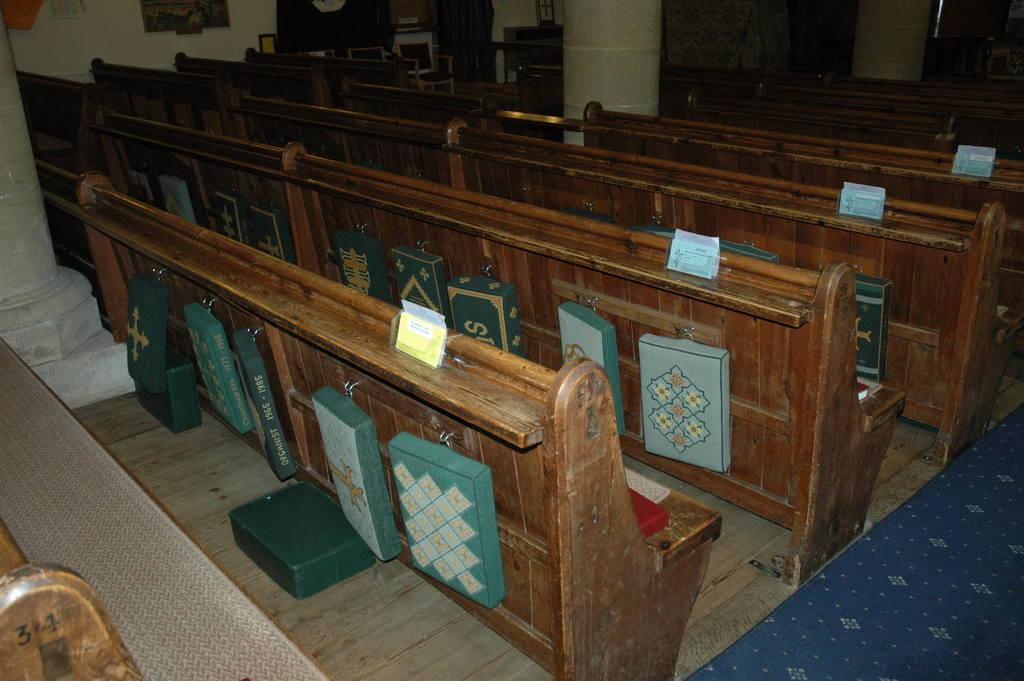What type of furniture is present in the image? There are benches in the image. What architectural elements can be seen in the image? There are pillars in the image. What is located at the bottom of the image? There is a carpet at the bottom of the image. What is visible in the background of the image? There is a wall in the background of the image. What object is used for displaying photos in the image? There is a photo frame in the image. What type of bomb is present in the image? There is no bomb present in the image. What is the desire of the person in the image? There is: There is no person present in the image, so it is impossible to determine their desires. 